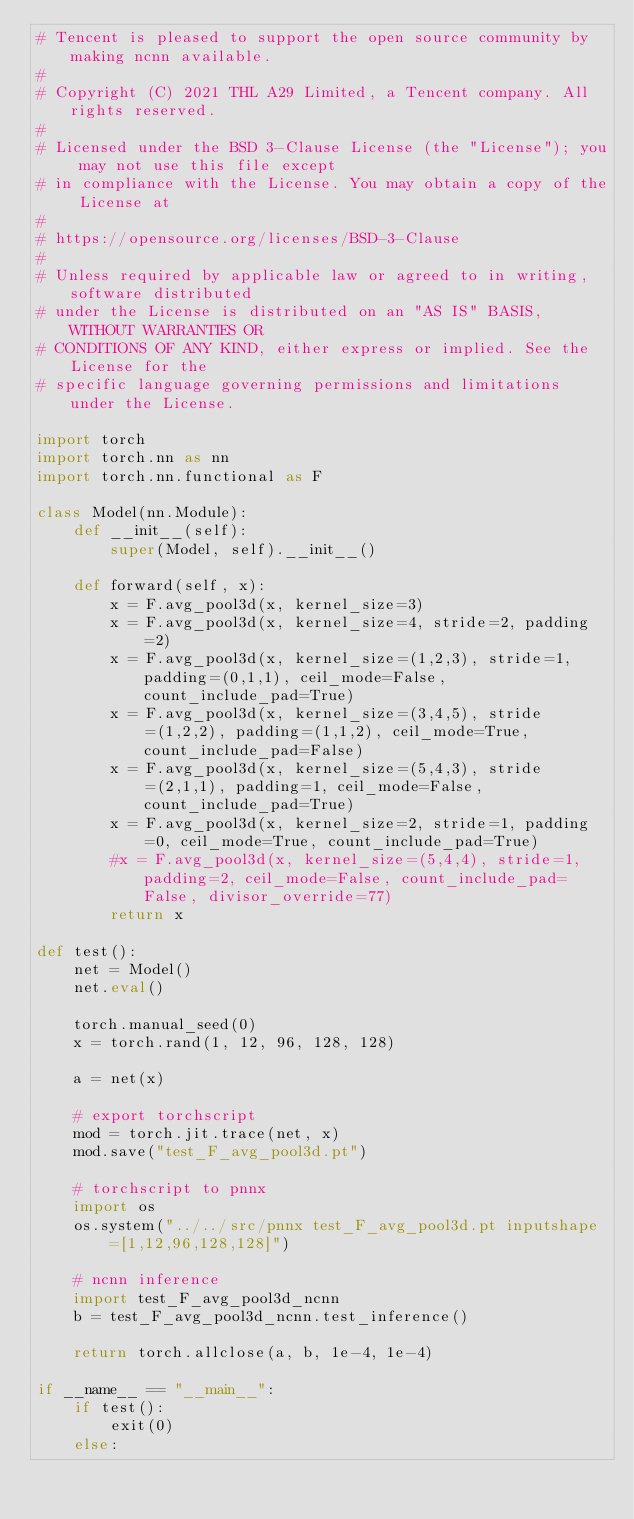Convert code to text. <code><loc_0><loc_0><loc_500><loc_500><_Python_># Tencent is pleased to support the open source community by making ncnn available.
#
# Copyright (C) 2021 THL A29 Limited, a Tencent company. All rights reserved.
#
# Licensed under the BSD 3-Clause License (the "License"); you may not use this file except
# in compliance with the License. You may obtain a copy of the License at
#
# https://opensource.org/licenses/BSD-3-Clause
#
# Unless required by applicable law or agreed to in writing, software distributed
# under the License is distributed on an "AS IS" BASIS, WITHOUT WARRANTIES OR
# CONDITIONS OF ANY KIND, either express or implied. See the License for the
# specific language governing permissions and limitations under the License.

import torch
import torch.nn as nn
import torch.nn.functional as F

class Model(nn.Module):
    def __init__(self):
        super(Model, self).__init__()

    def forward(self, x):
        x = F.avg_pool3d(x, kernel_size=3)
        x = F.avg_pool3d(x, kernel_size=4, stride=2, padding=2)
        x = F.avg_pool3d(x, kernel_size=(1,2,3), stride=1, padding=(0,1,1), ceil_mode=False, count_include_pad=True)
        x = F.avg_pool3d(x, kernel_size=(3,4,5), stride=(1,2,2), padding=(1,1,2), ceil_mode=True, count_include_pad=False)
        x = F.avg_pool3d(x, kernel_size=(5,4,3), stride=(2,1,1), padding=1, ceil_mode=False, count_include_pad=True)
        x = F.avg_pool3d(x, kernel_size=2, stride=1, padding=0, ceil_mode=True, count_include_pad=True)
        #x = F.avg_pool3d(x, kernel_size=(5,4,4), stride=1, padding=2, ceil_mode=False, count_include_pad=False, divisor_override=77)
        return x

def test():
    net = Model()
    net.eval()

    torch.manual_seed(0)
    x = torch.rand(1, 12, 96, 128, 128)

    a = net(x)

    # export torchscript
    mod = torch.jit.trace(net, x)
    mod.save("test_F_avg_pool3d.pt")

    # torchscript to pnnx
    import os
    os.system("../../src/pnnx test_F_avg_pool3d.pt inputshape=[1,12,96,128,128]")

    # ncnn inference
    import test_F_avg_pool3d_ncnn
    b = test_F_avg_pool3d_ncnn.test_inference()

    return torch.allclose(a, b, 1e-4, 1e-4)

if __name__ == "__main__":
    if test():
        exit(0)
    else:</code> 